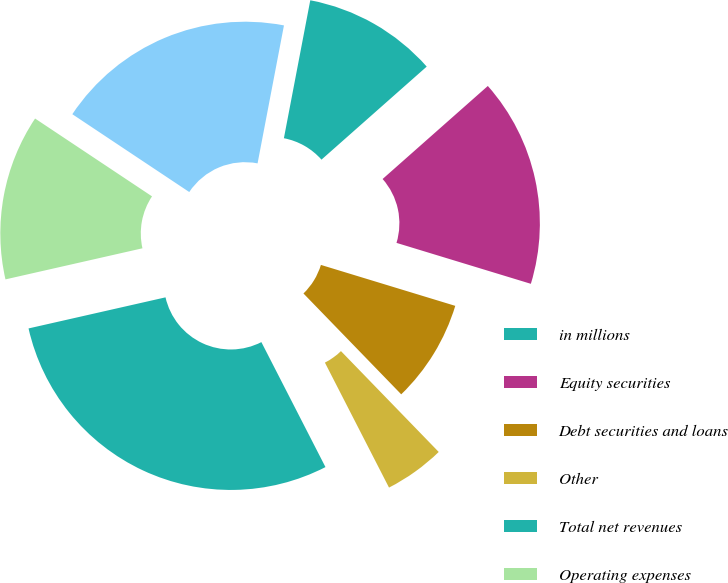Convert chart to OTSL. <chart><loc_0><loc_0><loc_500><loc_500><pie_chart><fcel>in millions<fcel>Equity securities<fcel>Debt securities and loans<fcel>Other<fcel>Total net revenues<fcel>Operating expenses<fcel>Pre-tax earnings/(loss)<nl><fcel>10.47%<fcel>16.23%<fcel>8.04%<fcel>4.71%<fcel>28.99%<fcel>12.9%<fcel>18.66%<nl></chart> 